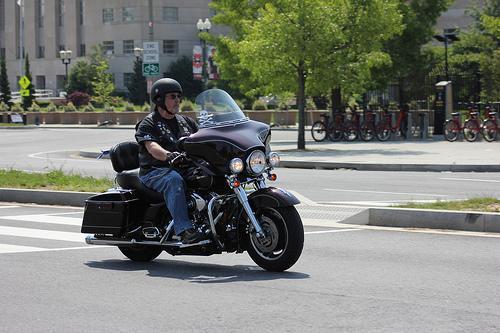How many motorcycles are there?
Give a very brief answer. 1. 